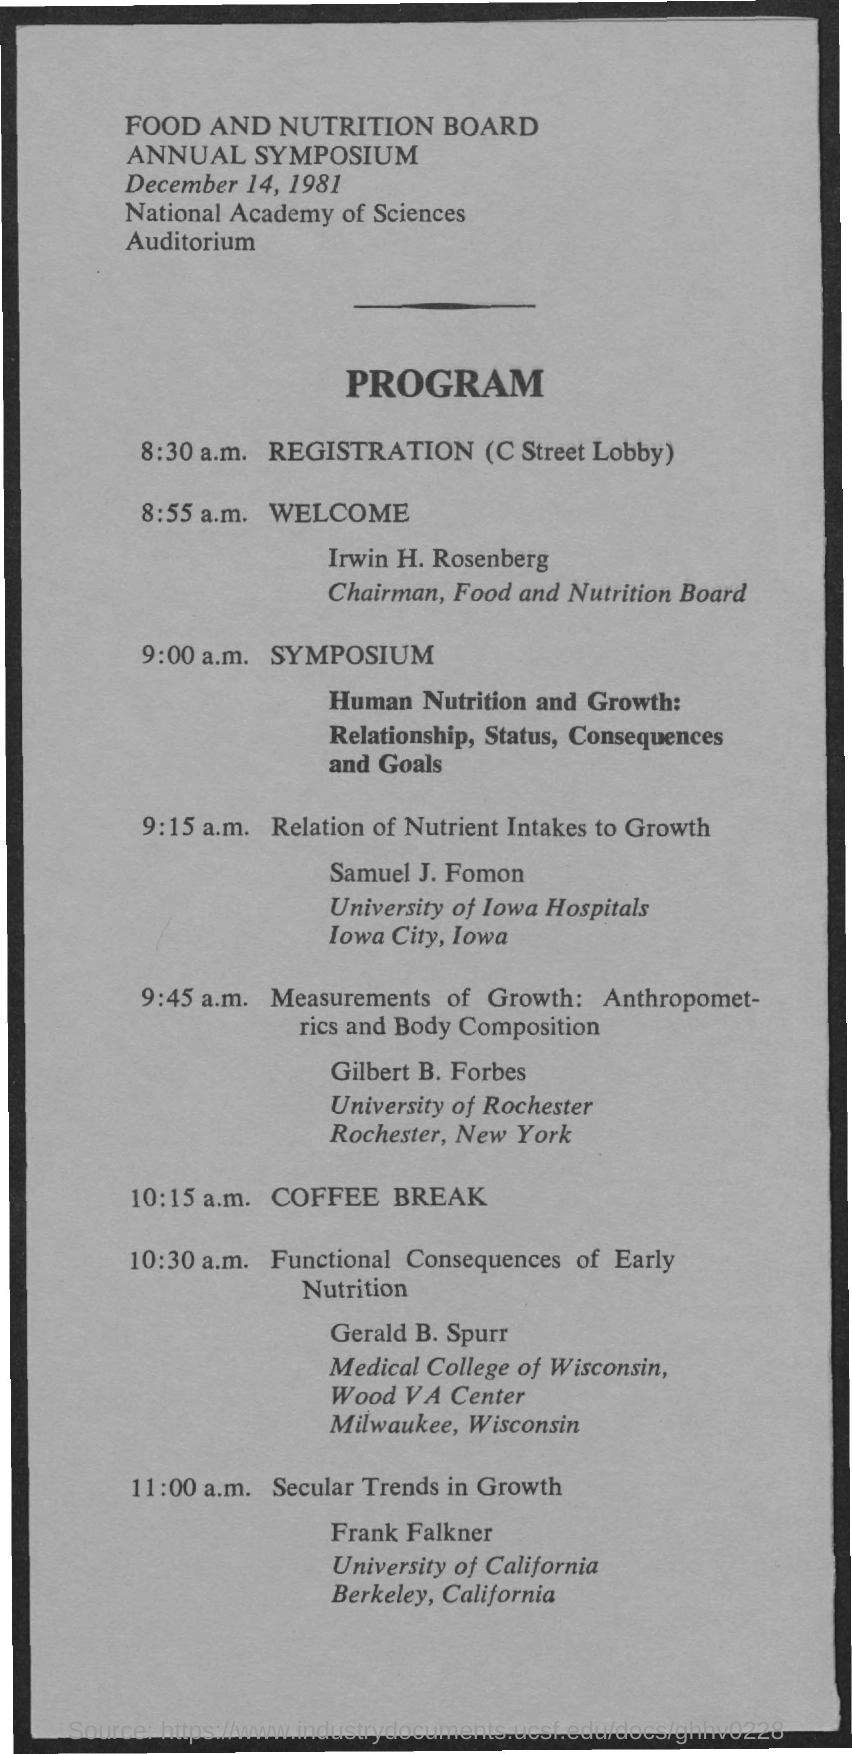Outline some significant characteristics in this image. The speaker is informing that Samuel J. Fomon is representing the University of Iowa Hospitals in Iowa City, Iowa. The chairman of the Food and Nutrition Board is Dr. Irwin H. Rosenberg. Gilbert B. Forbes is representing the University of Rochester, which is located in Rochester, New York. The annual symposium was held on December 14, 1981. Gerald B. Spurr is representing the Medical College of Wisconsin, Wood V, in Milwaukee, Wisconsin. 